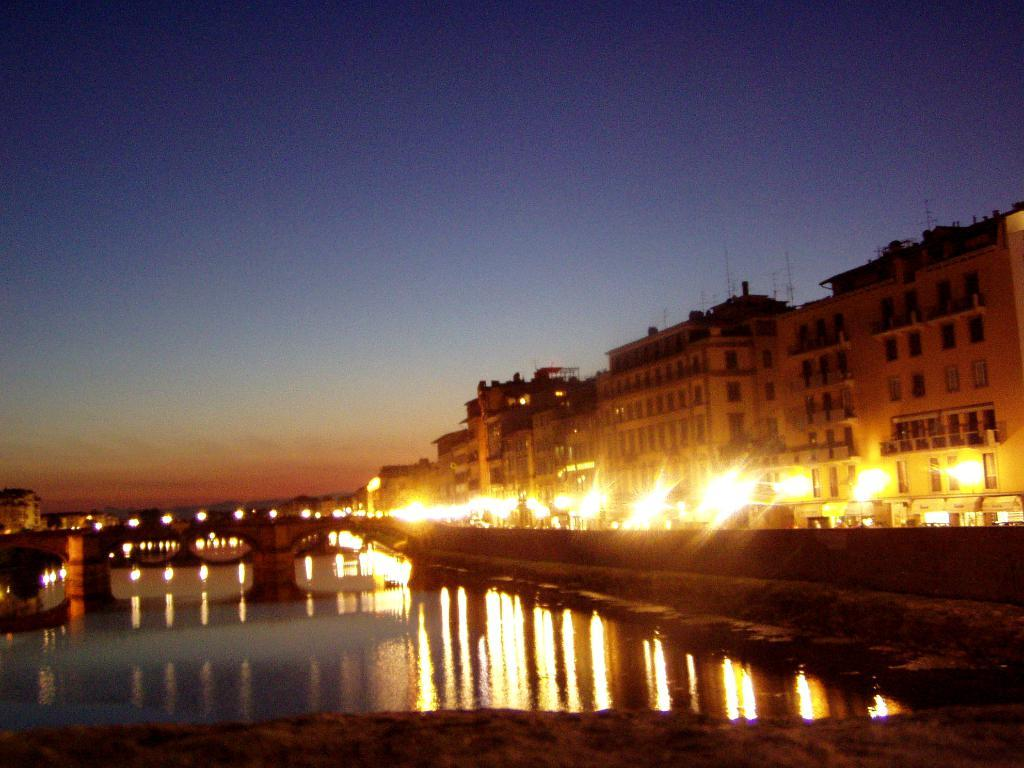What is the primary element visible in the image? There is water in the image. What else can be seen in the image besides the water? There are lights, buildings, and the sky visible in the image. Can you describe the buildings in the image? The buildings are part of the image's landscape, but their specific characteristics are not mentioned in the provided facts. What is visible in the background of the image? The sky is visible in the background of the image. How many pears are hanging from the lights in the image? There are no pears present in the image; it features water, lights, buildings, and the sky. 